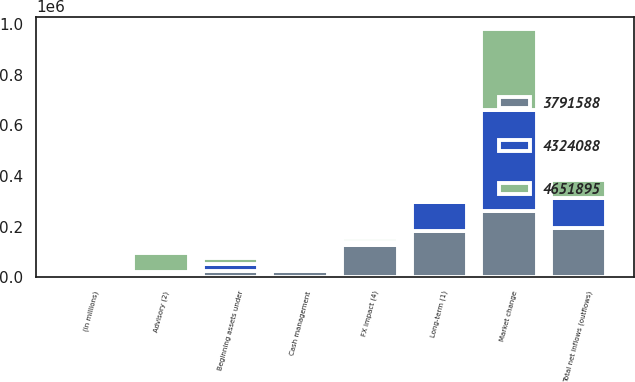Convert chart to OTSL. <chart><loc_0><loc_0><loc_500><loc_500><stacked_bar_chart><ecel><fcel>(in millions)<fcel>Beginning assets under<fcel>Long-term (1)<fcel>Cash management<fcel>Advisory (2)<fcel>Total net inflows (outflows)<fcel>Market change<fcel>FX impact (4)<nl><fcel>3.79159e+06<fcel>2014<fcel>25696<fcel>181253<fcel>25696<fcel>13173<fcel>193776<fcel>261682<fcel>127651<nl><fcel>4.32409e+06<fcel>2013<fcel>25696<fcel>117113<fcel>10056<fcel>7442<fcel>119727<fcel>398707<fcel>12866<nl><fcel>4.6519e+06<fcel>2012<fcel>25696<fcel>2465<fcel>5048<fcel>74540<fcel>71957<fcel>321377<fcel>15745<nl></chart> 